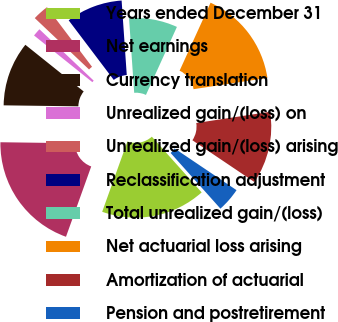Convert chart to OTSL. <chart><loc_0><loc_0><loc_500><loc_500><pie_chart><fcel>Years ended December 31<fcel>Net earnings<fcel>Currency translation<fcel>Unrealized gain/(loss) on<fcel>Unrealized gain/(loss) arising<fcel>Reclassification adjustment<fcel>Total unrealized gain/(loss)<fcel>Net actuarial loss arising<fcel>Amortization of actuarial<fcel>Pension and postretirement<nl><fcel>17.1%<fcel>19.73%<fcel>10.53%<fcel>1.32%<fcel>2.63%<fcel>9.21%<fcel>7.9%<fcel>15.79%<fcel>11.84%<fcel>3.95%<nl></chart> 